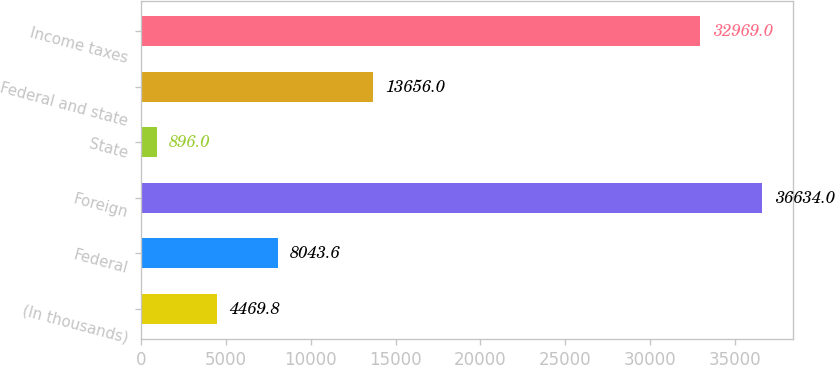<chart> <loc_0><loc_0><loc_500><loc_500><bar_chart><fcel>(In thousands)<fcel>Federal<fcel>Foreign<fcel>State<fcel>Federal and state<fcel>Income taxes<nl><fcel>4469.8<fcel>8043.6<fcel>36634<fcel>896<fcel>13656<fcel>32969<nl></chart> 